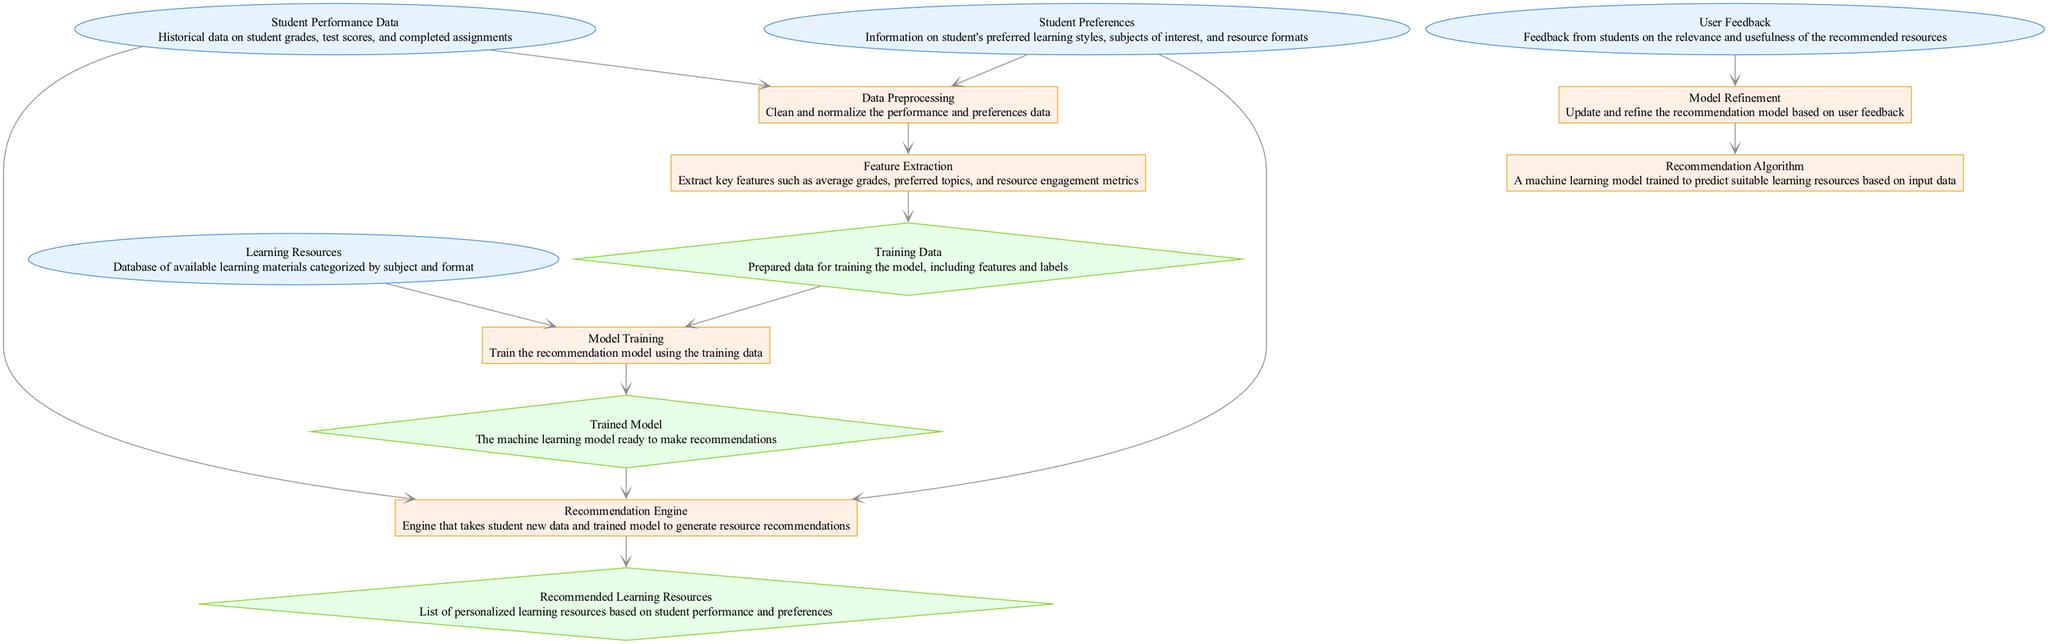What are the input components of the diagram? The input components are "Student Performance Data," "Student Preferences," and "Learning Resources." These components supply initial data needed for processing in the recommendation system.
Answer: Student Performance Data, Student Preferences, Learning Resources How many output components are there in the diagram? The output components are "Training Data," "Trained Model," and "Recommended Learning Resources." Counting these components yields a total of three output nodes.
Answer: 3 What process occurs after the "Data Preprocessing" component? After "Data Preprocessing," the next component is "Feature Extraction," which takes the cleaned data and extracts key features necessary for training the model.
Answer: Feature Extraction Which component refines the recommendation model? The "Model Refinement" component is responsible for updating and refining the recommendation model based on feedback from users.
Answer: Model Refinement What is the role of the "Recommendation Engine"? The "Recommendation Engine" generates resource recommendations by using student performance and preferences along with the trained model. It combines these inputs to provide personalized suggestions.
Answer: Generate resource recommendations How is the "Training Data" prepared? The "Training Data" is prepared by going through the "Feature Extraction" process, which takes features and labels from the cleaned and normalized data, allowing the model to learn during training.
Answer: By extracting features from the data What connects "User Feedback" to the recommendation process? "User Feedback" connects to "Model Refinement," which uses the feedback received to make adjustments and improve the recommendation algorithm over time, ensuring relevance and effectiveness.
Answer: Model Refinement What kind of data is used in "Model Training"? The "Model Training" process uses "Training Data," which includes all the features extracted from both student performance data and preferences to train the machine learning model effectively.
Answer: Training Data 